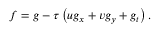<formula> <loc_0><loc_0><loc_500><loc_500>f = g - \tau \left ( u { { g } _ { x } } + v { { g } _ { y } } + { { g } _ { t } } \right ) .</formula> 